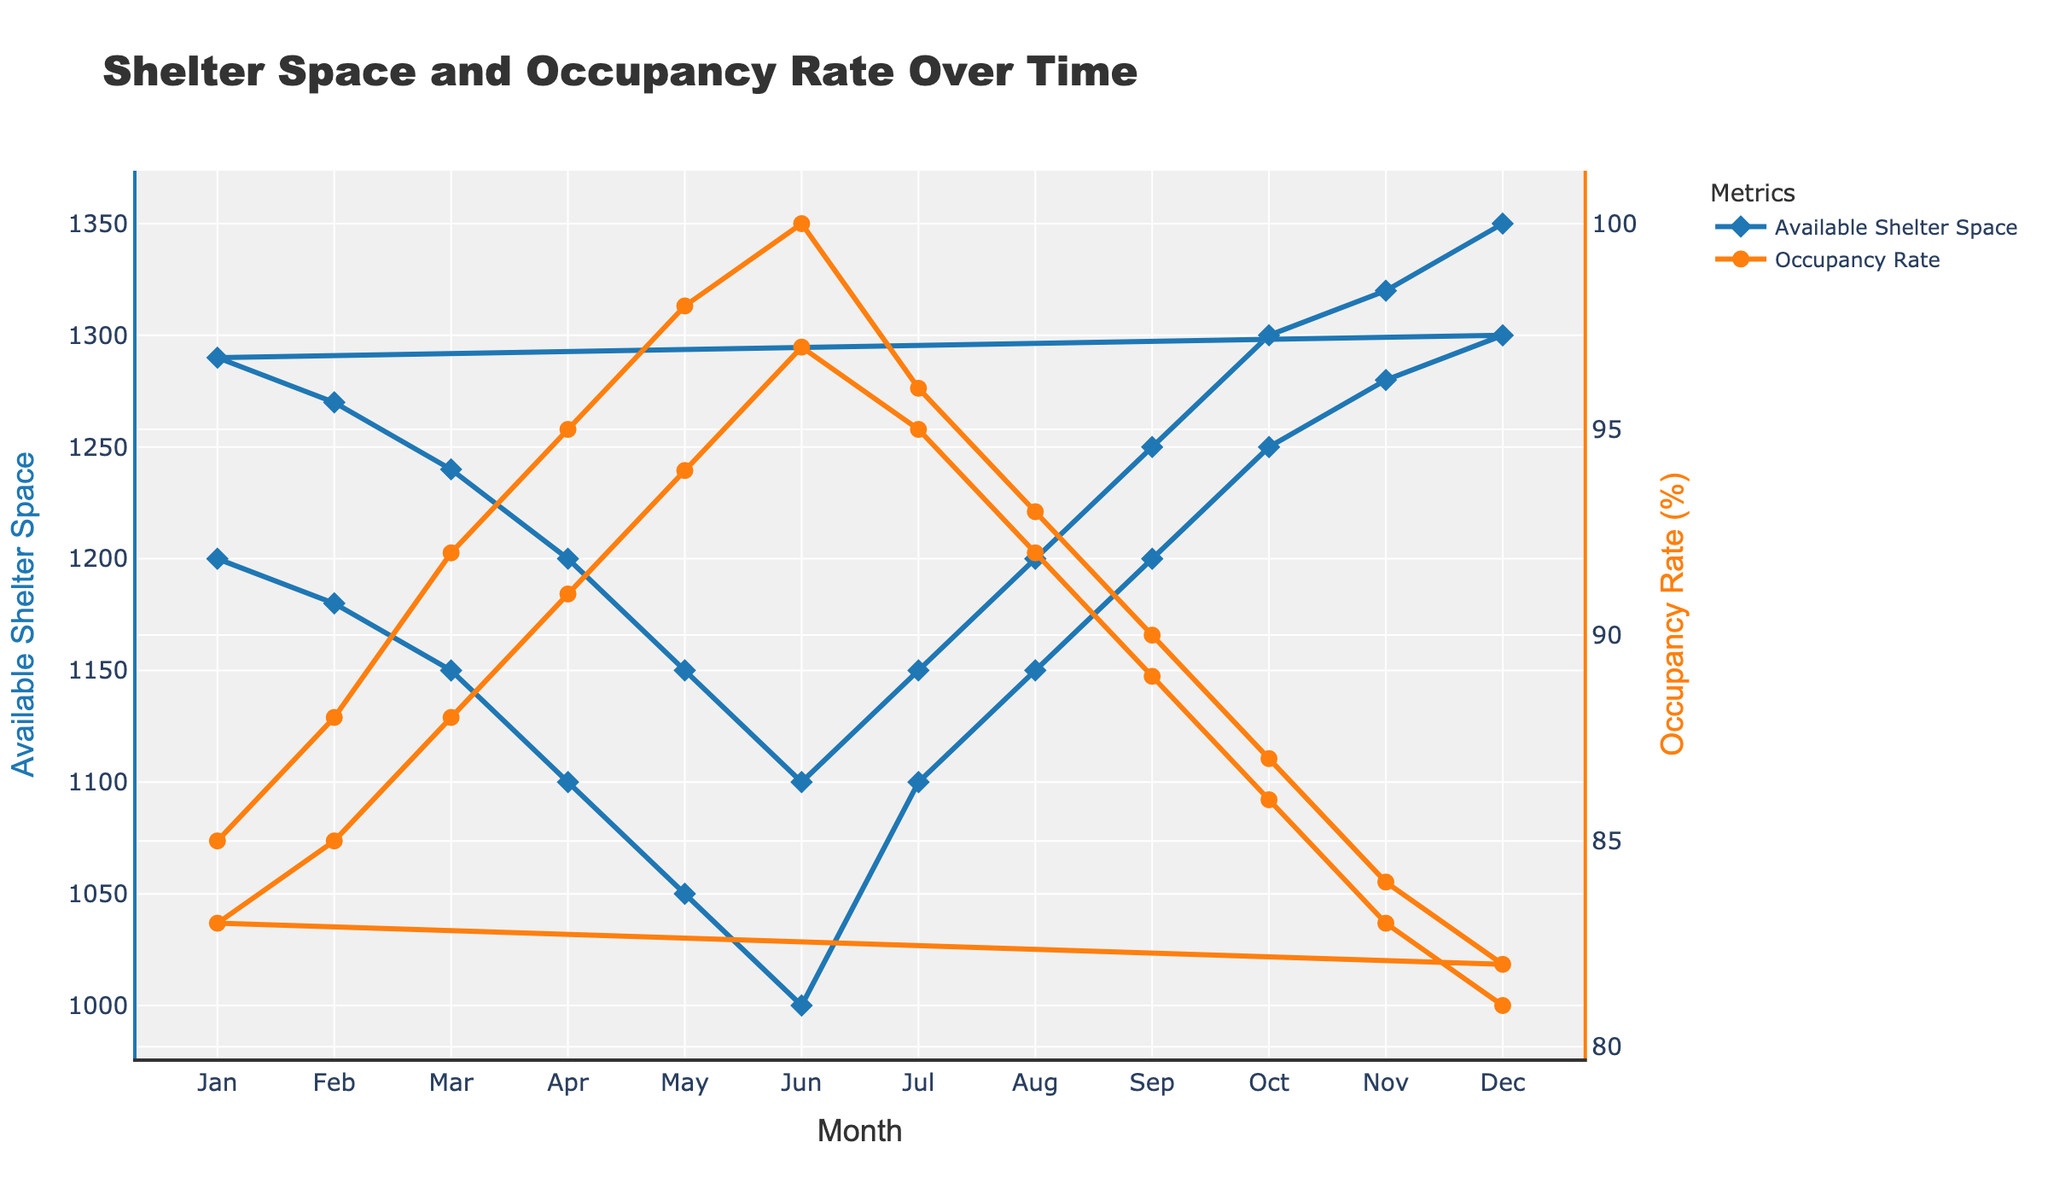How does the available shelter space in January compare to December of the first year? By visually comparing the y-values corresponding to January and December of the first year on the "Available Shelter Space" line (blue line), we see that January starts at 1200 and December ends at 1300.
Answer: Available shelter space increases by 100 In which month did the occupancy rate reach its peak in the first year? Looking at the peaks of the orange line (Occupancy Rate) for the first year, we observe that the highest point is in June, with an occupancy rate of 100%.
Answer: June What is the average occupancy rate in the second year? To find the average occupancy rate for the second year, we add up the occupancy rates from January (83), February (85), March (88), April (91), May (94), June (97), July (95), August (92), September (89), October (86), November (83), and December (81) and divide by 12. Calculation: (83 + 85 + 88 + 91 + 94 + 97 + 95 + 92 + 89 + 86 + 83 + 81) / 12 = 88.3.
Answer: 88.3% What is the difference in available shelter space between March and September of the second year? The available shelter space for March is shown at 1240 and for September at 1250. The difference is calculated as 1250 - 1240.
Answer: 10 Which year had a higher overall occupancy rate, the first year or the second year? To determine this, calculate the average occupancy rate for each year and compare them. First Year: (85 + 88 + 92 + 95 + 98 + 100 + 96 + 93 + 90 + 87 + 84 + 82) / 12 = 91.4. Second Year: (83 + 85 + 88 + 91 + 94 + 97 + 95 + 92 + 89 + 86 + 83 + 81) / 12 = 88.3. The first year has a higher overall occupancy rate.
Answer: First year What is the general trend observed for the available shelter space over the entire period? Observing the blue line over all the months, there is a gradual decrease in available shelter space during the first half of the year, reaching a low in June and then increasing for the rest of the year. This pattern is repeated in the second year.
Answer: Decreases first, then increases When does the occupancy rate start to decline after reaching 100% in the first year? In the first year, the occupancy rate reaches 100% in June, and by July, it starts declining as indicated by the fall in the orange line to 96%.
Answer: July Is there a negative correlation between available shelter space and occupancy rate observed in the figure? By analyzing the trends where the blue and orange lines move oppositely, a negative correlation can be observed. When available shelter space decreases, the occupancy rate tends to increase and vice versa.
Answer: Yes 